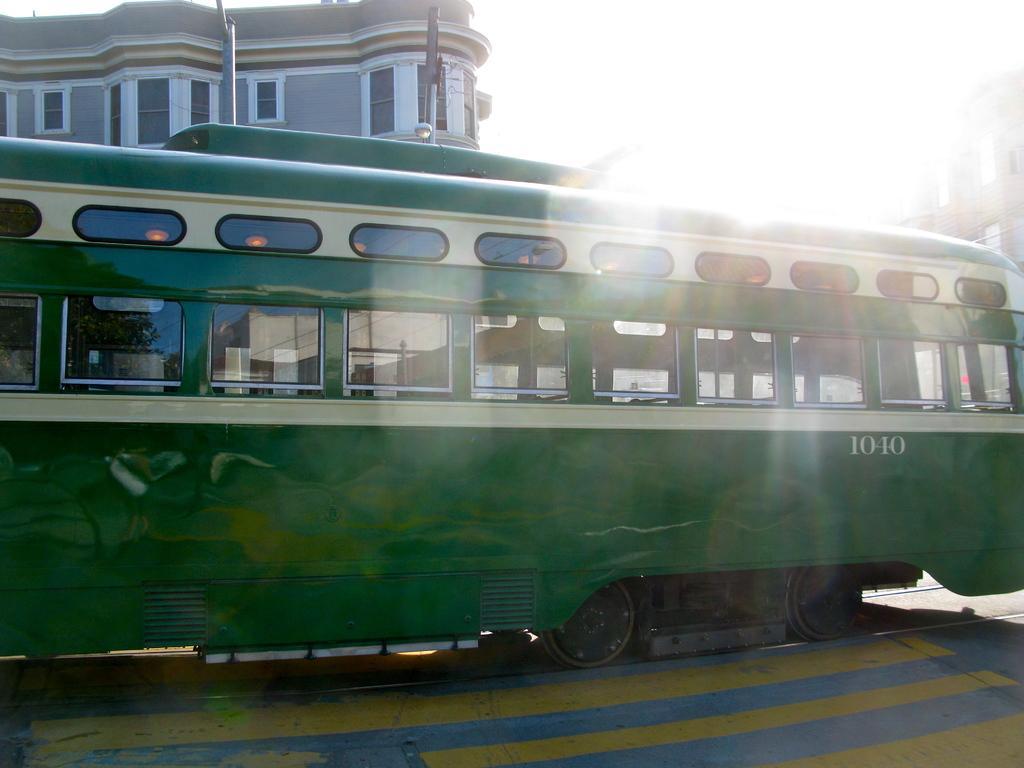How would you summarize this image in a sentence or two? There is a tram in the middle of this image, and there is a building in the background. We can see a sky at the top of this image. 